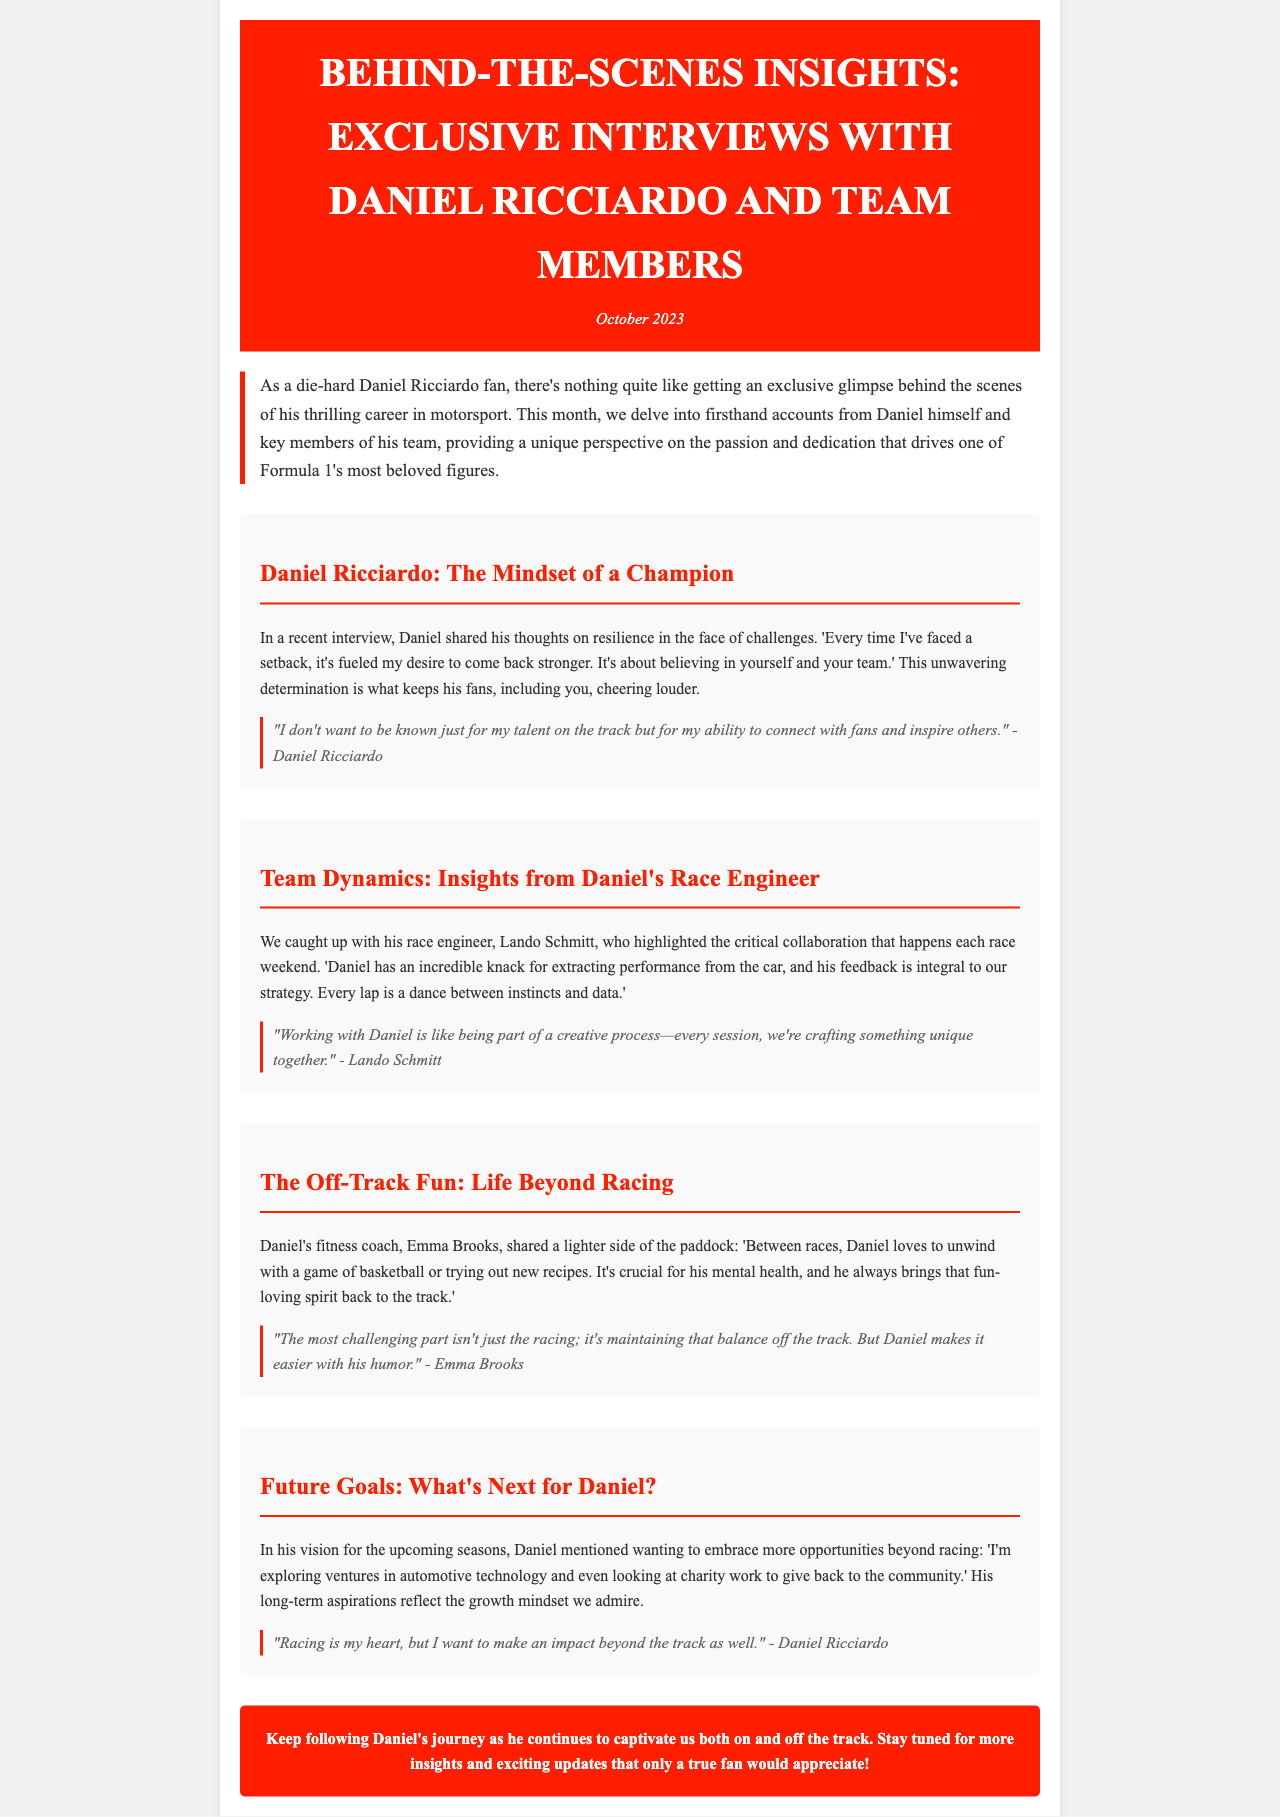What month is this newsletter from? The newsletter explicitly states the publication date at the start: October 2023.
Answer: October 2023 Who is Daniel's race engineer mentioned in the newsletter? The newsletter provides the name of Daniel's race engineer, who is cited in a section.
Answer: Lando Schmitt What is the main focus of Daniel's long-term aspirations? Daniel's future goals section highlights his intentions that reflect a growth mindset.
Answer: Charity work What sport does Daniel enjoy playing off-track? Daniel's fitness coach shares a recreational activity he enjoys during downtime.
Answer: Basketball What quote reflects Daniel Ricciardo’s desire to connect with fans? The document features a quote that illustrates Daniel's perspective on his public persona and relationship with fans.
Answer: "I don't want to be known just for my talent on the track but for my ability to connect with fans and inspire others." What does Emma Brooks emphasize about Daniel's off-track activities? Emma mentions how Daniel balances his racing life with activities that contribute to his mental health.
Answer: Humor What does Daniel believe is crucial in racing, as mentioned in his interview? Daniel expresses a belief in resilience as a key factor in his approach to challenges.
Answer: Resilience 